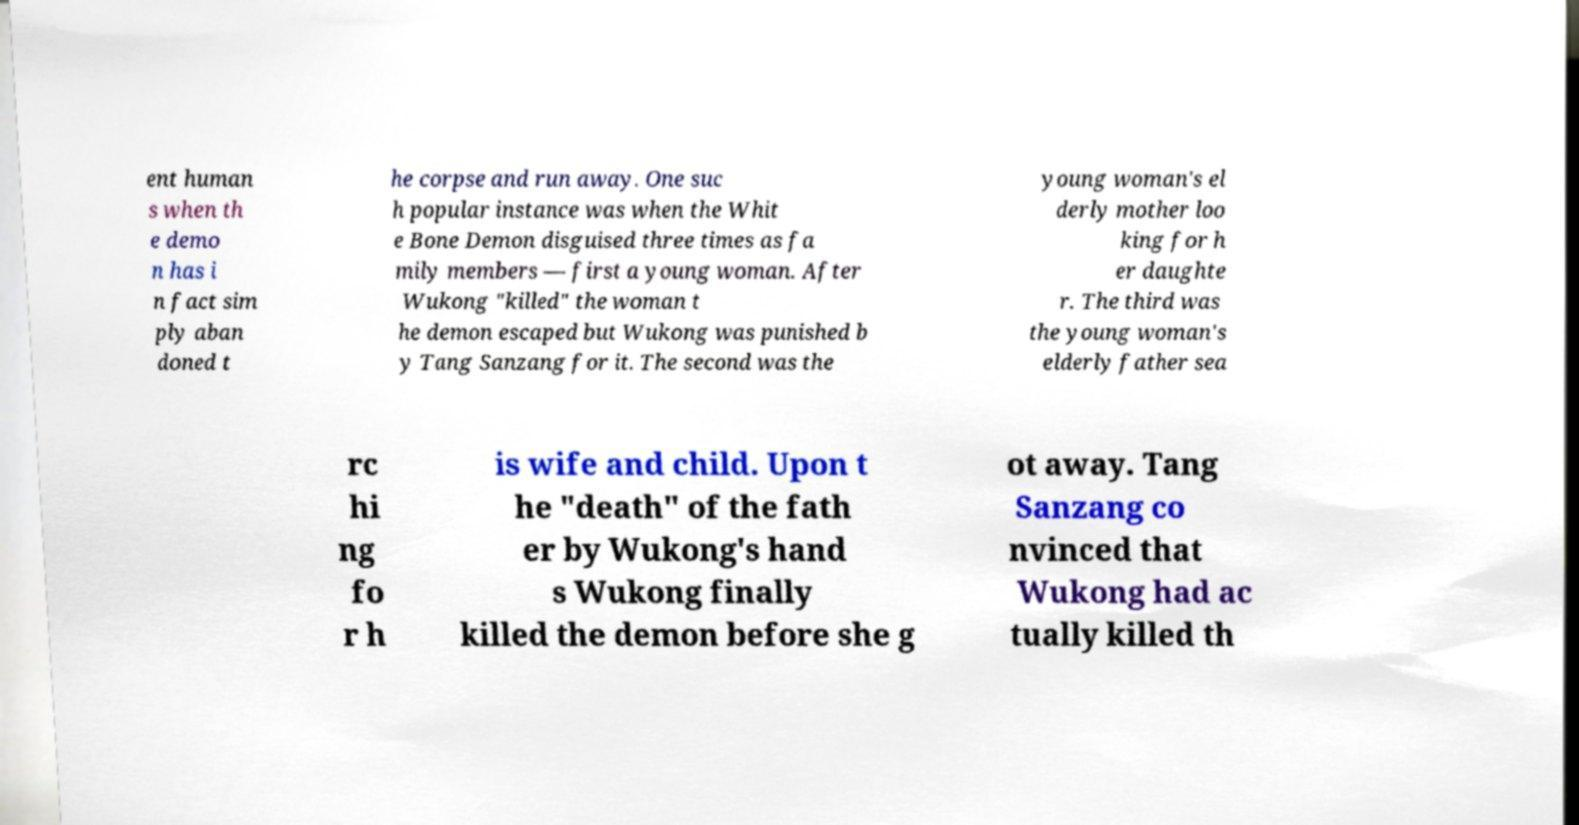What messages or text are displayed in this image? I need them in a readable, typed format. ent human s when th e demo n has i n fact sim ply aban doned t he corpse and run away. One suc h popular instance was when the Whit e Bone Demon disguised three times as fa mily members — first a young woman. After Wukong "killed" the woman t he demon escaped but Wukong was punished b y Tang Sanzang for it. The second was the young woman's el derly mother loo king for h er daughte r. The third was the young woman's elderly father sea rc hi ng fo r h is wife and child. Upon t he "death" of the fath er by Wukong's hand s Wukong finally killed the demon before she g ot away. Tang Sanzang co nvinced that Wukong had ac tually killed th 